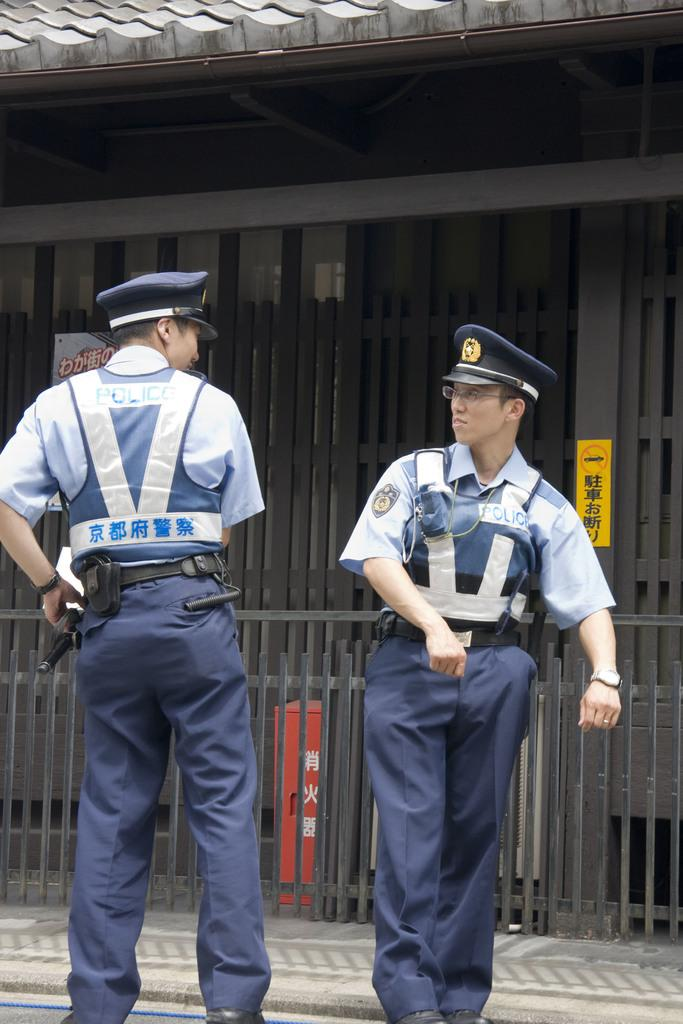How many people are in the foreground of the picture? There are two persons in the foreground of the picture. What can be seen in the foreground of the picture besides the people? There is a road, a pavement, and a railing in the foreground of the picture. What is located in the middle of the picture? There are gates of a building in the middle of the picture. What is visible at the top of the picture? There is a roof visible at the top of the picture. What type of game is being played by the minister in the picture? There is no minister or game present in the picture. Is the quilt used as a prop in the picture? There is no quilt present in the picture. 